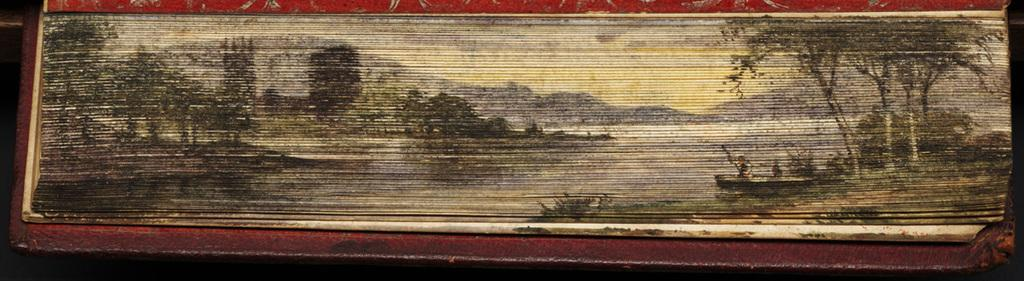What type of landscape is depicted in the painting? The painting contains hills and a lake. What other natural elements can be seen in the painting? There are trees in the painting. What activity are the two people engaged in? Two people are sailing in a boat in the painting. What type of wrench is being used by the people sailing in the boat? There is no wrench present in the painting; the people are sailing in a boat without any tools visible. 